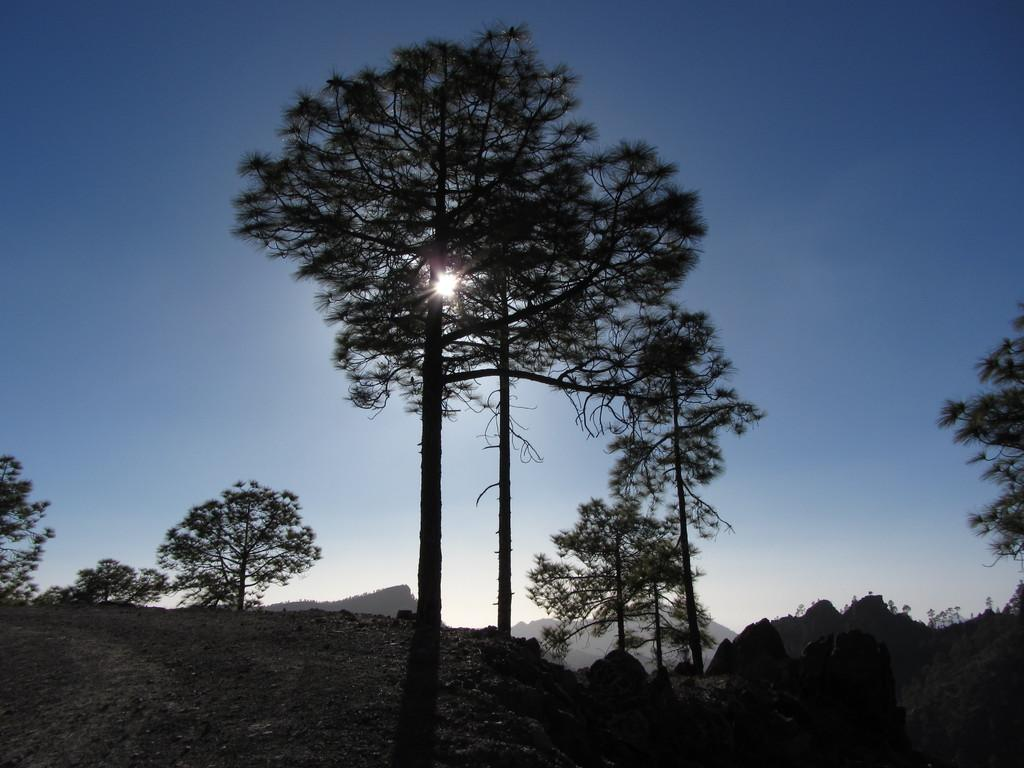What type of natural elements can be seen in the image? There are trees and hills in the image. What celestial body is visible in the image? The sun is visible in the image. What is the color of the sky in the background of the image? The sky is blue in the background of the image. Where are the father and mom in the image? There is no father or mom present in the image. What type of livestock can be seen grazing on the hills in the image? There are no animals, including cattle, visible in the image. 